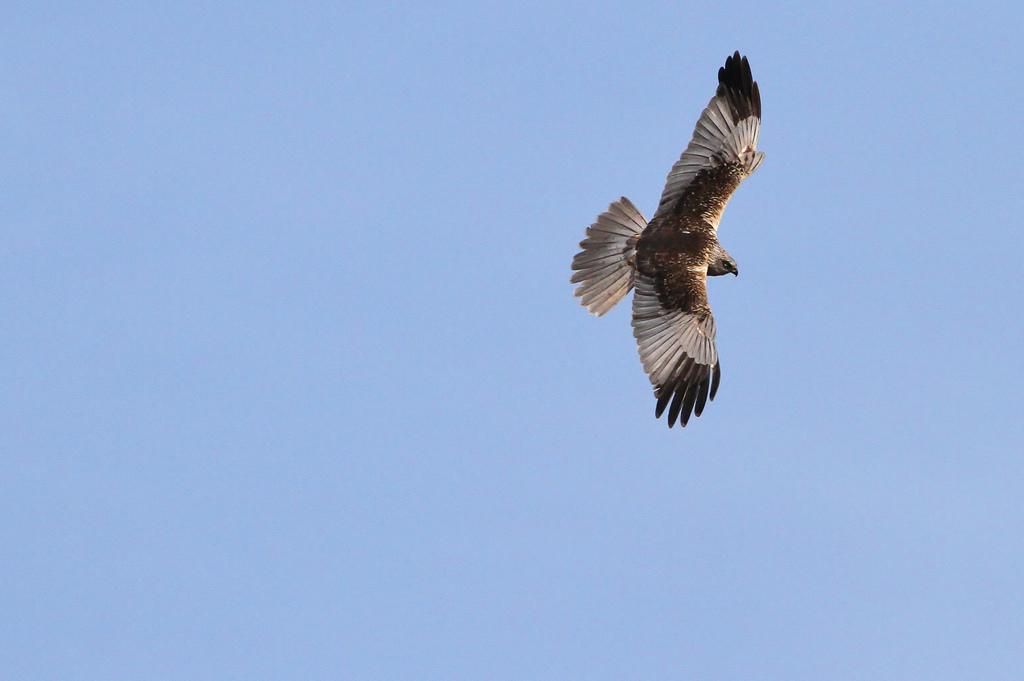Describe this image in one or two sentences. In this image, we can see a bird is flying in the air. Background there is a sky. 